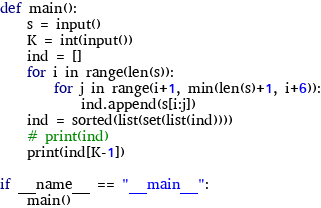<code> <loc_0><loc_0><loc_500><loc_500><_Python_>def main():
    s = input()
    K = int(input())
    ind = []
    for i in range(len(s)):
        for j in range(i+1, min(len(s)+1, i+6)):
            ind.append(s[i:j])
    ind = sorted(list(set(list(ind))))
    # print(ind)
    print(ind[K-1])

if __name__ == "__main__":
    main()</code> 